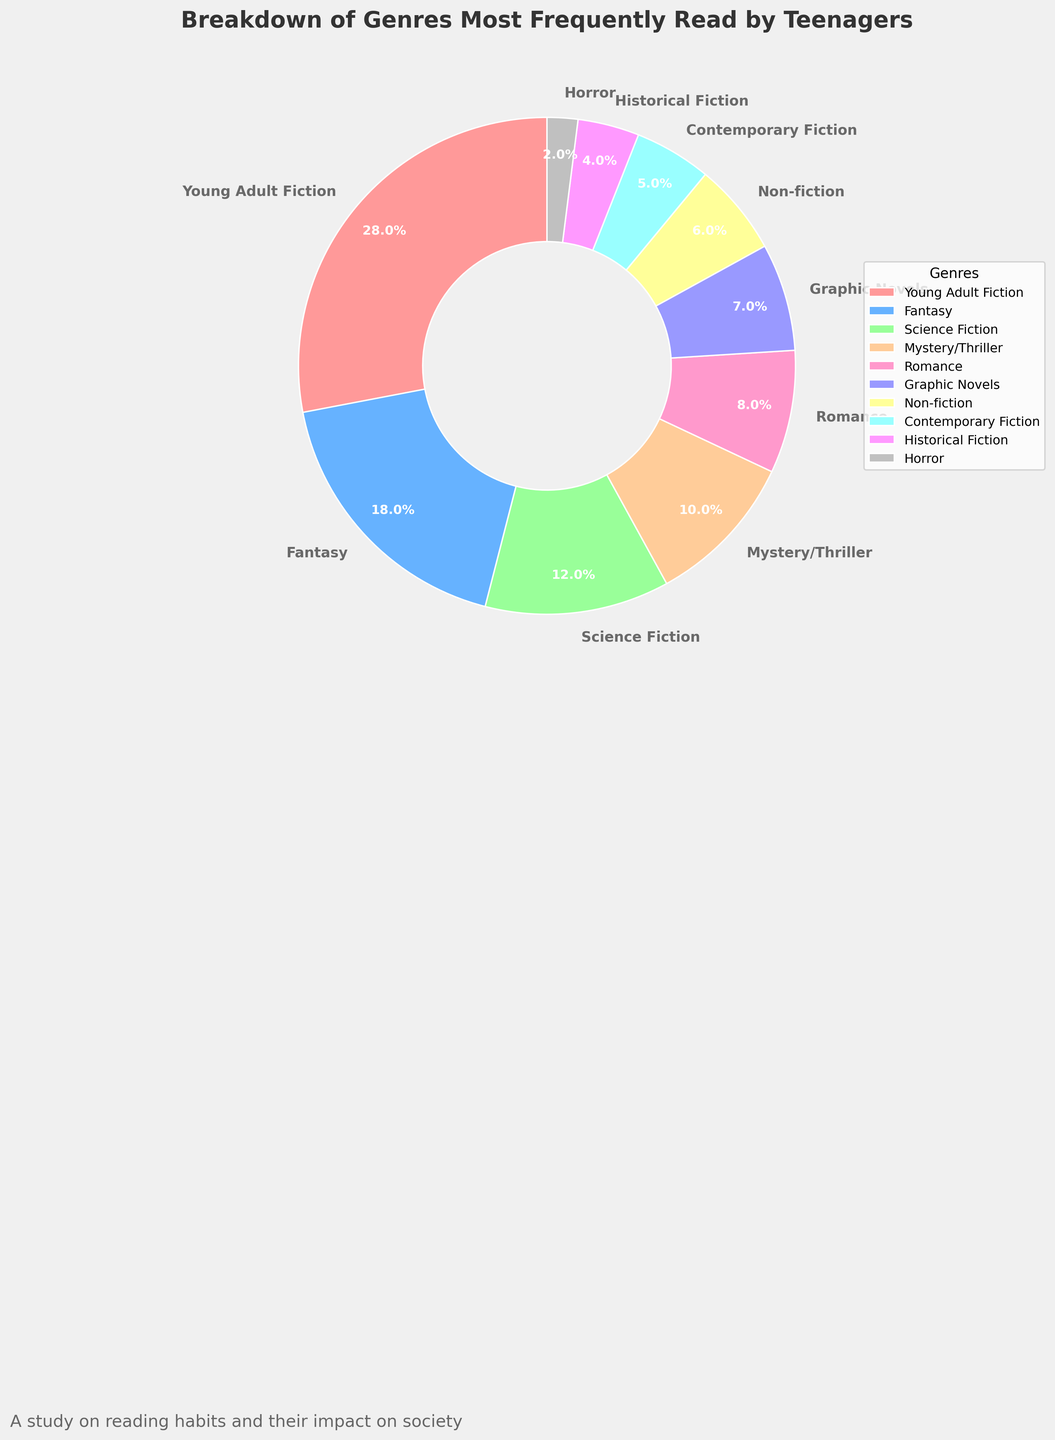What is the most frequently read genre by teenagers? The most frequently read genre can be identified by looking for the largest section of the pie chart. The chart shows that "Young Adult Fiction" represents 28%.
Answer: Young Adult Fiction Which genre has the least percentage of readers? By identifying the smallest wedge in the pie chart, we can see that "Horror" occupies the smallest section, representing only 2%.
Answer: Horror What is the combined percentage of readers for Fantasy and Science Fiction genres? To find the combined percentage, add the percentages of both genres: Fantasy (18%) + Science Fiction (12%) = 30%.
Answer: 30% How does the percentage of readers of Mystery/Thriller compare to Romance? The percentage for Mystery/Thriller is 10% while Romance is 8%. Comparing these, Mystery/Thriller has a higher percentage of readers.
Answer: Mystery/Thriller has more readers What are the three genres read by the fewest teenagers? By examining the smallest wedges in the pie chart, the three genres with the least readers are Horror (2%), Historical Fiction (4%), and Contemporary Fiction (5%).
Answer: Horror, Historical Fiction, Contemporary Fiction Which genre uses the color red in the chart? The wedge colored red in the chart corresponds to "Young Adult Fiction."
Answer: Young Adult Fiction What is the total percentage of readers for Graphic Novels, Non-fiction, and Contemporary Fiction? Combine the percentages for these genres: Graphic Novels (7%) + Non-fiction (6%) + Contemporary Fiction (5%) = 18%.
Answer: 18% Is the proportion of Romance readers greater than Non-fiction readers? Compare the percentages for Romance (8%) and Non-fiction (6%). Romance has a greater proportion.
Answer: Yes What is the difference in percentage between the most and least frequently read genres? Subtract the smallest percentage (Horror, 2%) from the largest percentage (Young Adult Fiction, 28%): 28% - 2% = 26%.
Answer: 26% Which two genres together make up nearly a third of the chart? Looking for a combination close to one-third (33.3%), we see that Young Adult Fiction (28%) and Horror (2%) add up to 30%, which is near a third.
Answer: Young Adult Fiction and Horror 